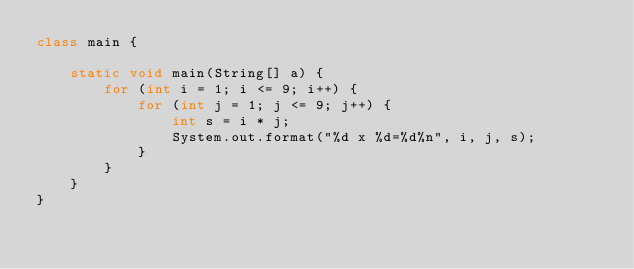Convert code to text. <code><loc_0><loc_0><loc_500><loc_500><_Java_>class main {

	static void main(String[] a) {
		for (int i = 1; i <= 9; i++) {
			for (int j = 1; j <= 9; j++) {
				int s = i * j;
				System.out.format("%d x %d=%d%n", i, j, s); 
			}
		}
	}
}</code> 